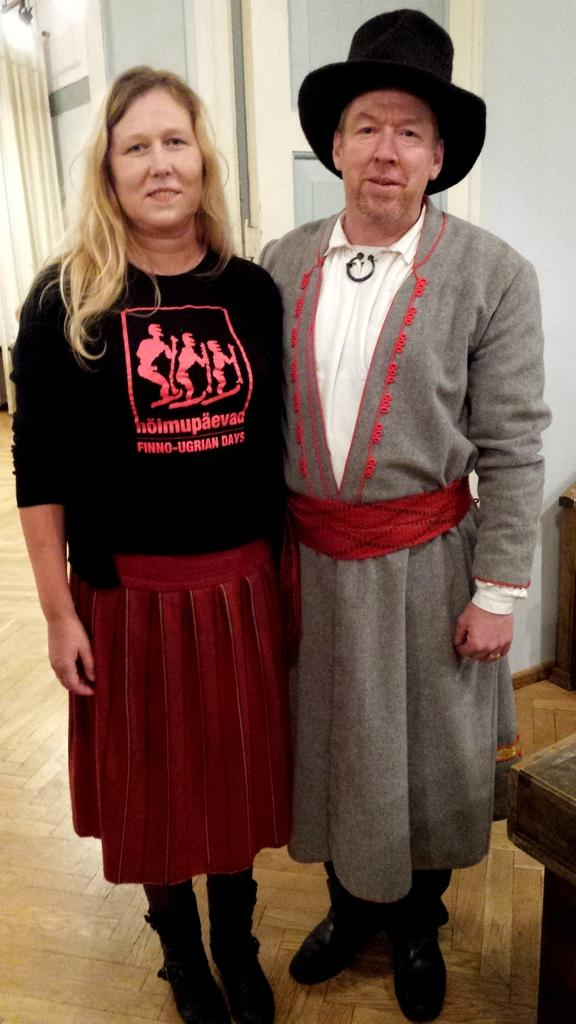Who is present in the image? There is a woman and a man in the image. What are they wearing on their heads? Both the woman and the man are wearing hats. Where are they standing? They are standing on the floor. What can be seen in the background of the image? There is a curtain and a wall in the background. Can you see a snail on the roof in the image? There is no roof or snail present in the image. 